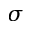Convert formula to latex. <formula><loc_0><loc_0><loc_500><loc_500>\sigma</formula> 